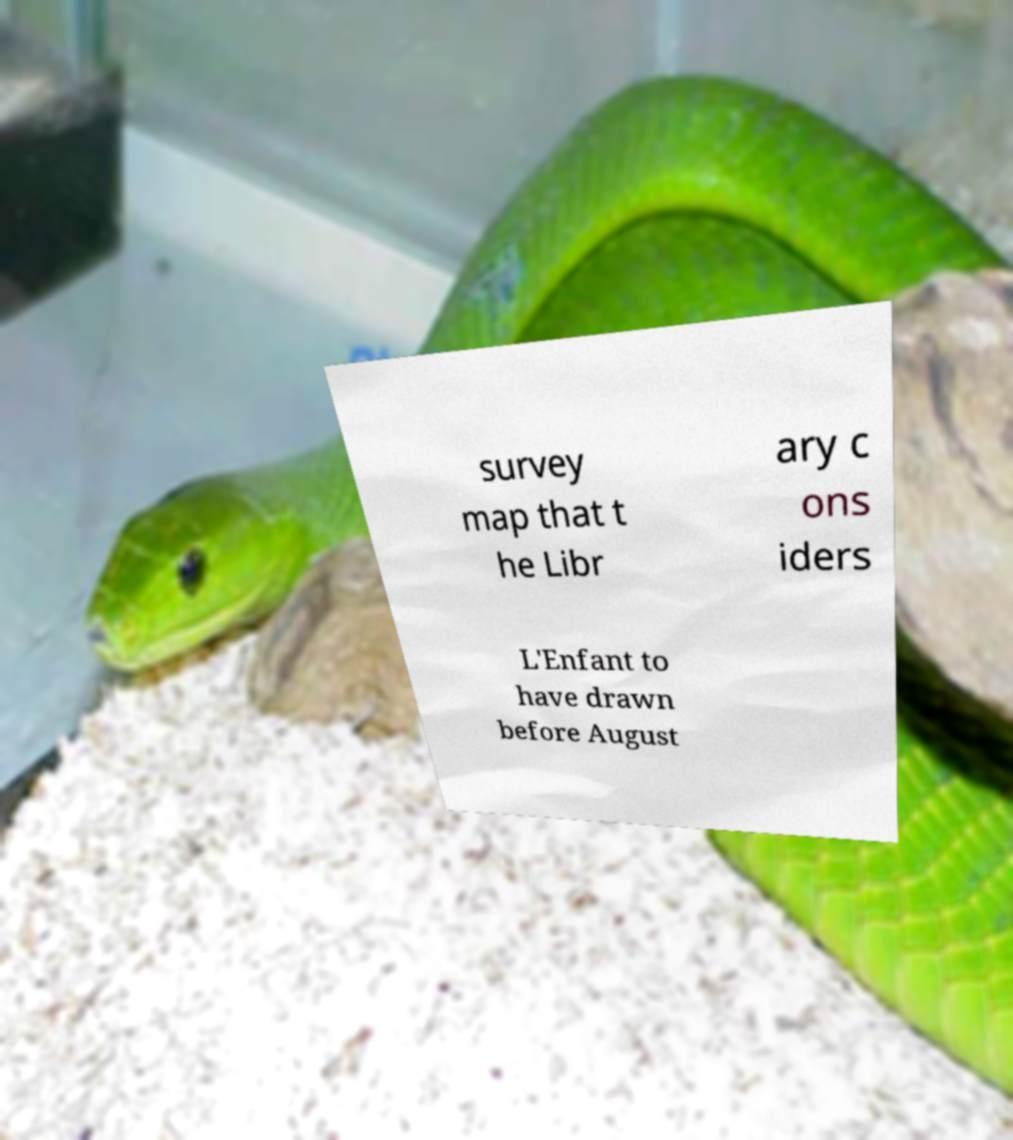Can you read and provide the text displayed in the image?This photo seems to have some interesting text. Can you extract and type it out for me? survey map that t he Libr ary c ons iders L'Enfant to have drawn before August 